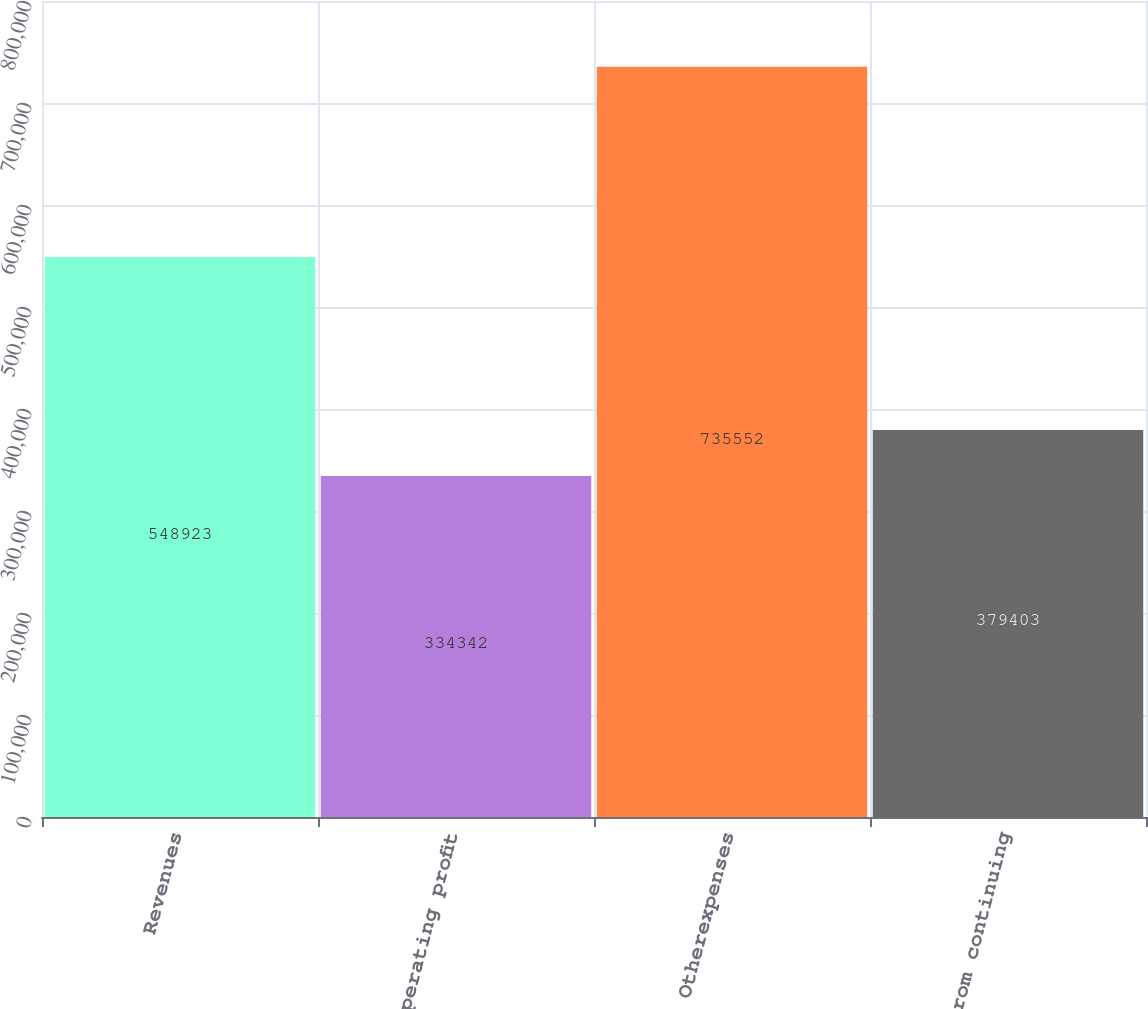<chart> <loc_0><loc_0><loc_500><loc_500><bar_chart><fcel>Revenues<fcel>Operating profit<fcel>Otherexpenses<fcel>Loss from continuing<nl><fcel>548923<fcel>334342<fcel>735552<fcel>379403<nl></chart> 